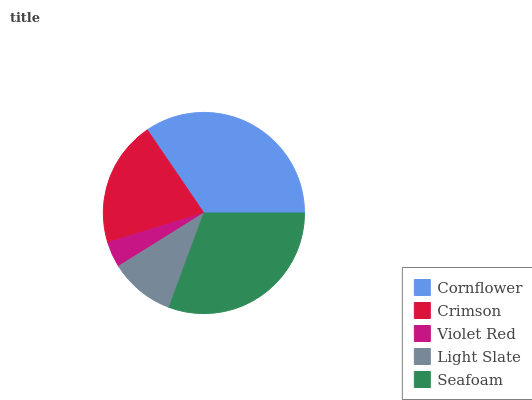Is Violet Red the minimum?
Answer yes or no. Yes. Is Cornflower the maximum?
Answer yes or no. Yes. Is Crimson the minimum?
Answer yes or no. No. Is Crimson the maximum?
Answer yes or no. No. Is Cornflower greater than Crimson?
Answer yes or no. Yes. Is Crimson less than Cornflower?
Answer yes or no. Yes. Is Crimson greater than Cornflower?
Answer yes or no. No. Is Cornflower less than Crimson?
Answer yes or no. No. Is Crimson the high median?
Answer yes or no. Yes. Is Crimson the low median?
Answer yes or no. Yes. Is Light Slate the high median?
Answer yes or no. No. Is Cornflower the low median?
Answer yes or no. No. 